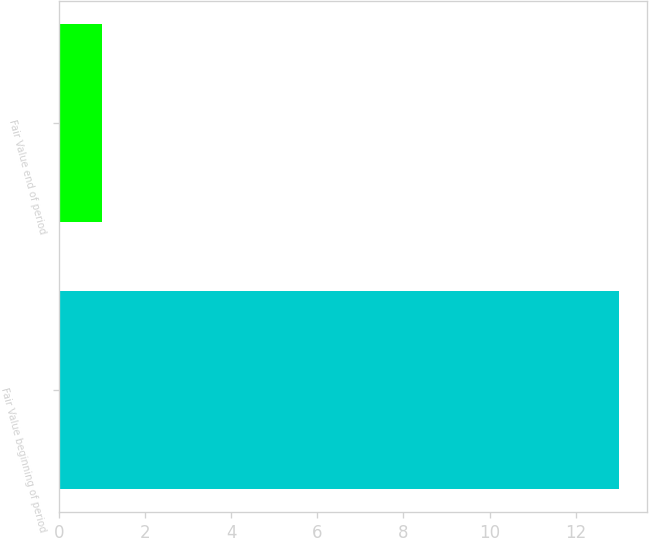Convert chart to OTSL. <chart><loc_0><loc_0><loc_500><loc_500><bar_chart><fcel>Fair Value beginning of period<fcel>Fair Value end of period<nl><fcel>13<fcel>1<nl></chart> 